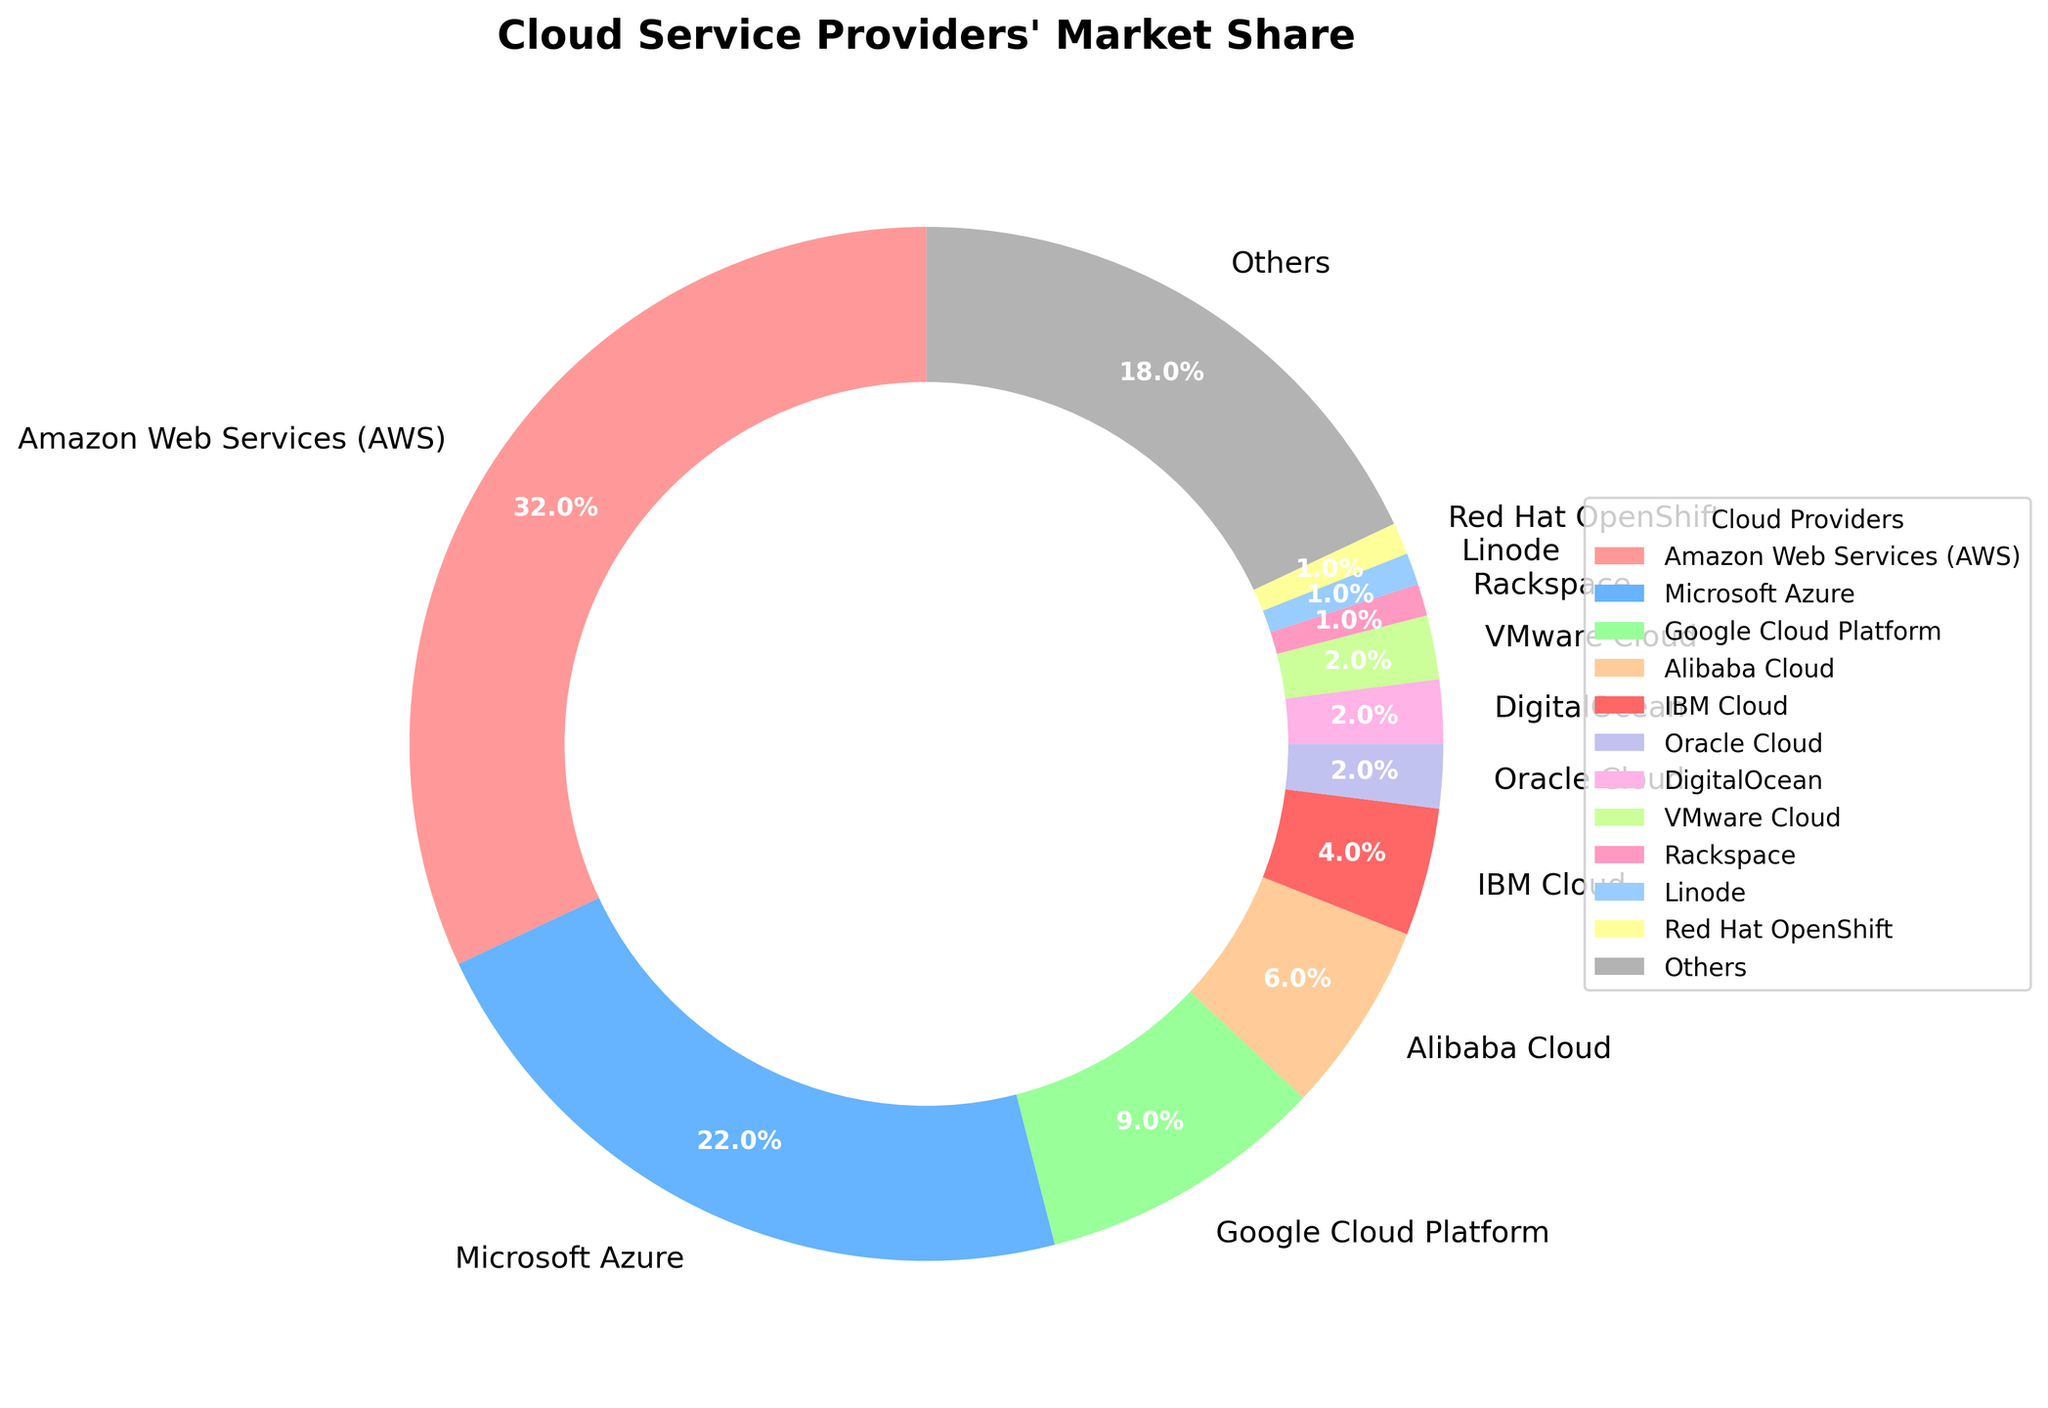What percentage of the market share do AWS and Microsoft Azure hold together? AWS holds 32% and Microsoft Azure holds 22%. By adding these two percentages together, we get 32% + 22% = 54%.
Answer: 54% Which cloud service provider has the smallest market share? According to the chart, multiple providers (Rackspace, Linode, Red Hat OpenShift) each have a market share of 1%, which is the smallest.
Answer: Rackspace, Linode, Red Hat OpenShift What is the combined market share of Google Cloud Platform, IBM Cloud, and Alibaba Cloud? Google Cloud Platform holds 9%, IBM Cloud holds 4%, and Alibaba Cloud holds 6%. Adding these, we get 9% + 4% + 6% = 19%.
Answer: 19% Is the market share of "Others" greater than the combined market share of all providers with less than 4% individually? Providers with less than 4% individually are Oracle Cloud, DigitalOcean, VMware Cloud, Rackspace, Linode, and Red Hat OpenShift. Their combined market share is 2% + 2% + 2% + 1% + 1% + 1% = 9%. The market share for "Others" is 18%, which is greater than 9%.
Answer: Yes Among the listed cloud providers, which one has the highest market share and what is it? The chart shows that Amazon Web Services (AWS) has the highest market share at 32%.
Answer: AWS, 32% What is the difference in market share between the provider with the highest share and the provider with the second-highest share? AWS has the highest share at 32% and Microsoft Azure has the second-highest at 22%. The difference is 32% - 22% = 10%.
Answer: 10% What color represents Google Cloud Platform in the chart? In the pie chart, Google Cloud Platform is represented by the third color. The third color from the color list is light green.
Answer: light green How much more market share does AWS have compared to Google Cloud Platform? AWS has 32% market share and Google Cloud Platform has 9%. The difference is 32% - 9% = 23%.
Answer: 23% If you combine the market shares of Alibaba Cloud, IBM Cloud, and Oracle Cloud, is it larger than Microsoft's Azure market share? The market shares are Alibaba Cloud (6%), IBM Cloud (4%), Oracle Cloud (2%). Their combined share is 6% + 4% + 2% = 12%. Microsoft Azure holds 22%, which is greater than 12%.
Answer: No What is the total market share of all cloud providers not from the United States? The non-US based providers (with significant individual market share) are Alibaba Cloud (6%) and others collectively including the “Others” category (18%). Total market share is 6% + 18% = 24%.
Answer: 24% 